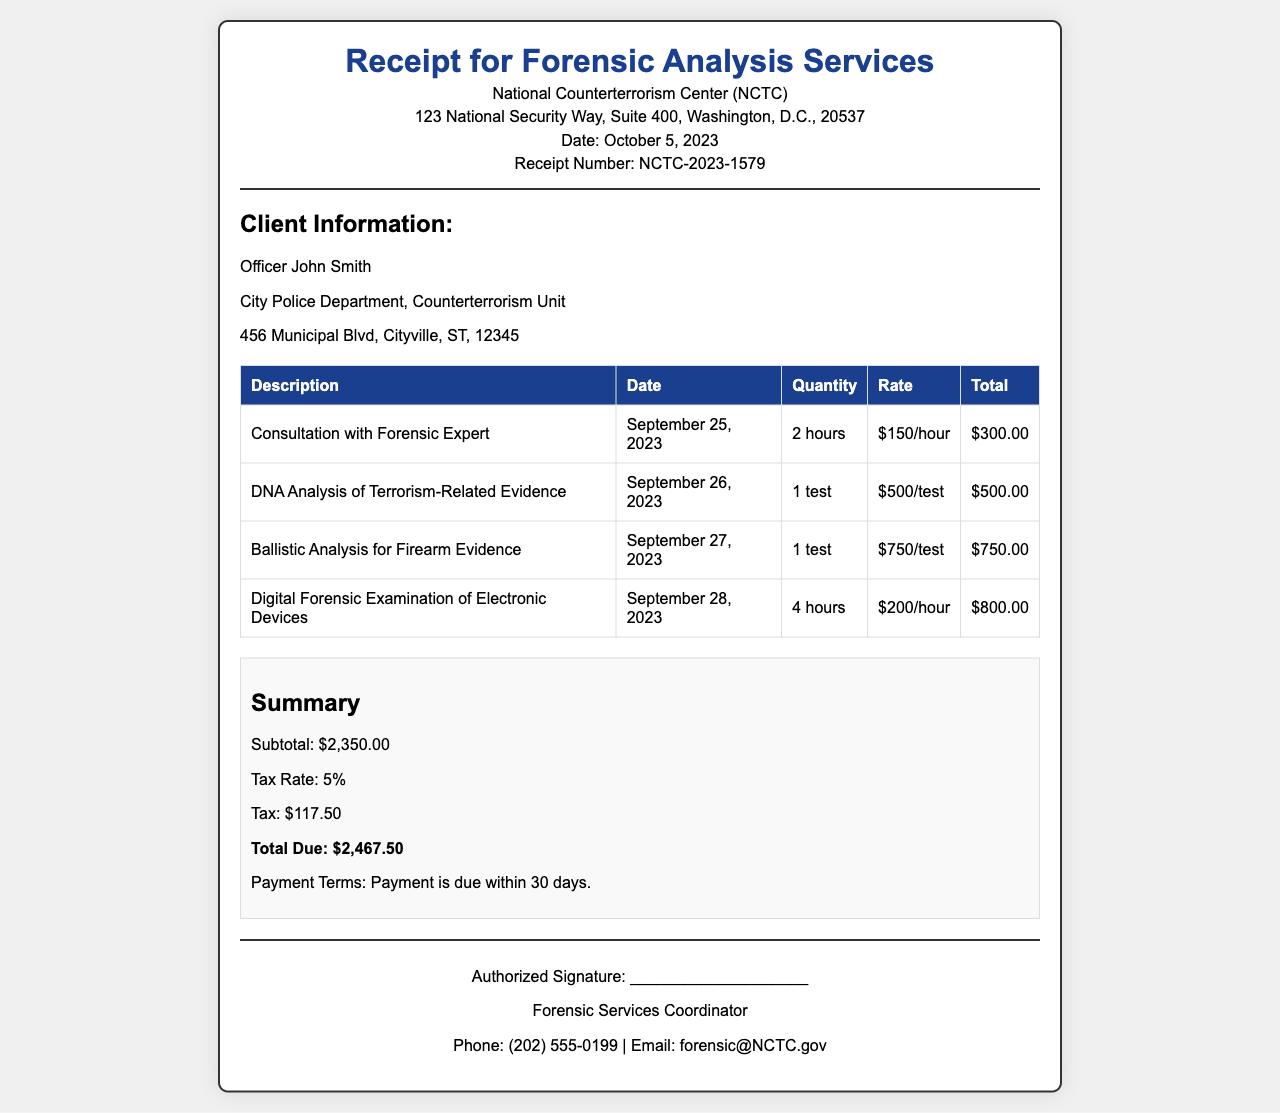What is the receipt number? The receipt number is provided at the top of the document under its title, which identifies the transaction specifically.
Answer: NCTC-2023-1579 Who is the client? The client's name is mentioned in the client information section of the document, identifying the person receiving the services.
Answer: Officer John Smith What is the total due amount? The total due amount is the final cost calculated at the end of the receipt, including subtotal and tax.
Answer: $2,467.50 What date was the consultation with the forensic expert performed? The date of the consultation is indicated in the table under the corresponding service description.
Answer: September 25, 2023 How many hours were spent on the digital forensic examination? The quantity of hours for the digital forensic examination is shown in the table, reflecting how long the service took.
Answer: 4 hours What is the tax rate applied to the services? The tax rate can be found in the summary section, specifying the percentage added to the subtotal.
Answer: 5% What service had the highest cost? The costs for each service are outlined in the table, and the service with the highest cost can be determined from those values.
Answer: Ballistic Analysis for Firearm Evidence What is the contact email for forensic services? The email for forensic services is listed in the footer of the document, providing a way to reach out for further inquiries.
Answer: forensic@NCTC.gov When is payment due? The payment terms section of the receipt specifies when payment must be made.
Answer: Within 30 days 